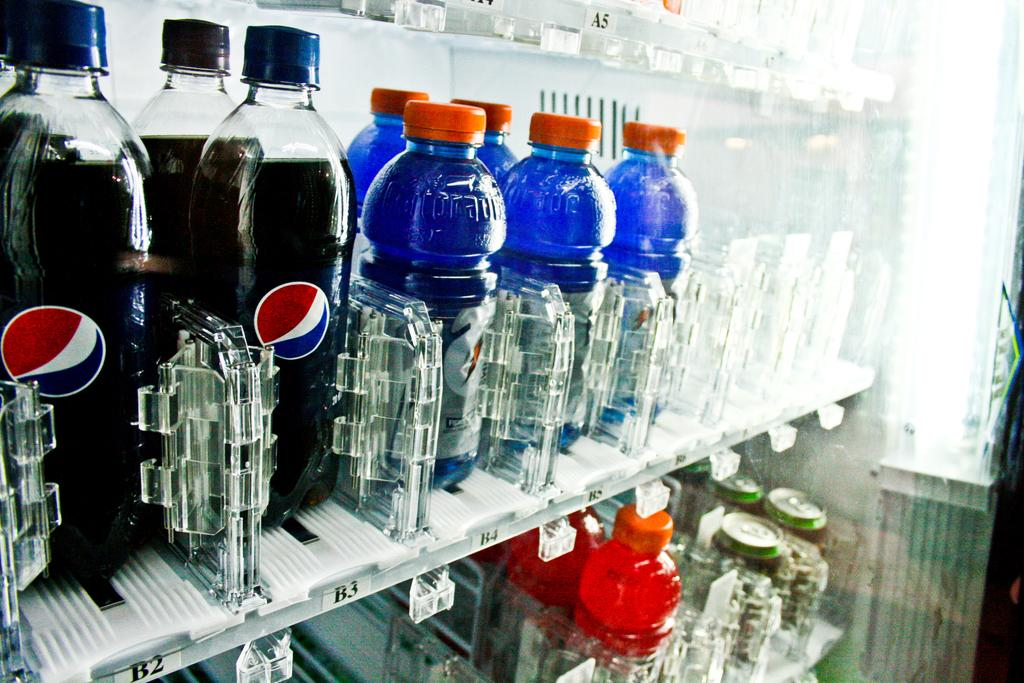What objects are present in the image that are used for holding liquids? There are bottles in the image. Where are the bottles located in the image? The bottles are in a rack. What other type of container can be seen in the image? There are tins in the image. How many chairs can be seen in the image? There are no chairs present in the image. Is there any smoke visible in the image? There is no smoke present in the image. 